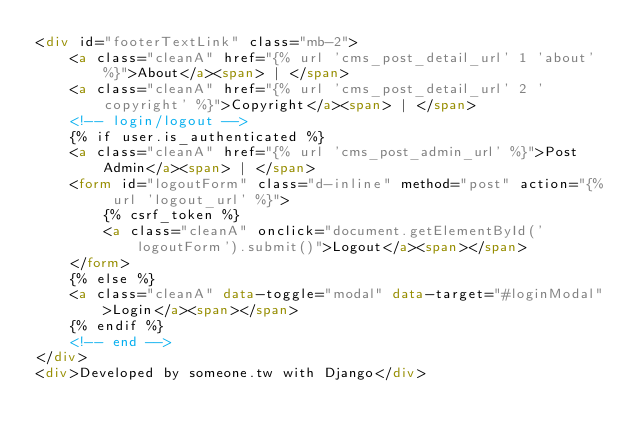<code> <loc_0><loc_0><loc_500><loc_500><_HTML_><div id="footerTextLink" class="mb-2">
    <a class="cleanA" href="{% url 'cms_post_detail_url' 1 'about' %}">About</a><span> | </span>
    <a class="cleanA" href="{% url 'cms_post_detail_url' 2 'copyright' %}">Copyright</a><span> | </span>
    <!-- login/logout -->
    {% if user.is_authenticated %}
    <a class="cleanA" href="{% url 'cms_post_admin_url' %}">Post Admin</a><span> | </span>
    <form id="logoutForm" class="d-inline" method="post" action="{% url 'logout_url' %}">
        {% csrf_token %}
        <a class="cleanA" onclick="document.getElementById('logoutForm').submit()">Logout</a><span></span>
    </form>
    {% else %}
    <a class="cleanA" data-toggle="modal" data-target="#loginModal">Login</a><span></span>
    {% endif %}
    <!-- end -->
</div>
<div>Developed by someone.tw with Django</div></code> 